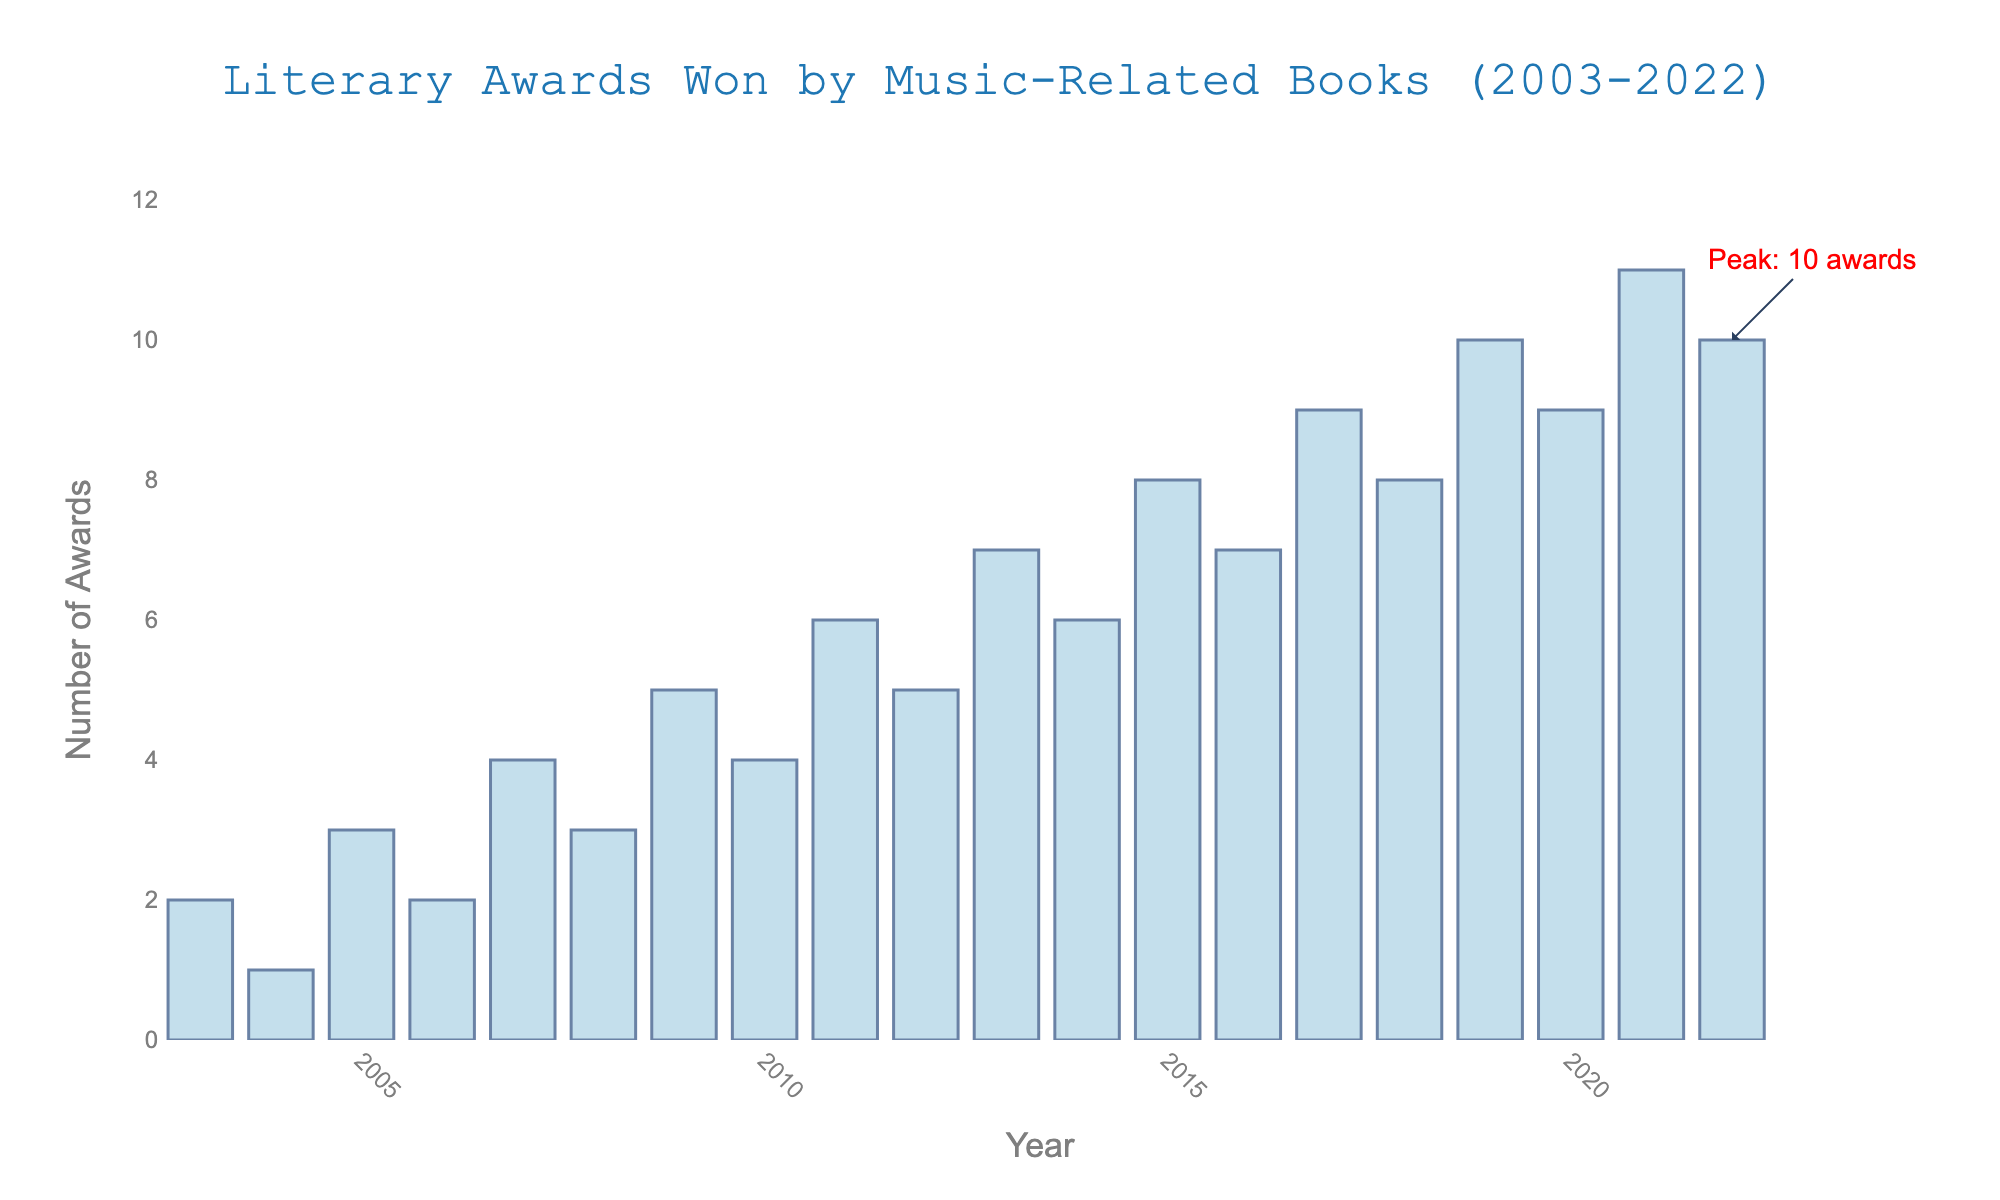How many awards were won by music-related books in 2022? Look at the bar corresponding to the year 2022 and read off the number of awards.
Answer: 10 Which year saw the highest number of awards? Find the tallest bar in the chart which corresponds to the year with the highest number of awards. The annotation on the chart also highlights the peak.
Answer: 2021 How many more awards were won in 2019 compared to 2015? Identify the number of awards in 2019 (10) and 2015 (8) from the respective bars and subtract to find the difference.
Answer: 2 What is the average number of awards won per year from 2003 to 2022? Sum the total number of awards from all years and divide by the number of years (20). Total awards: 2+1+3+2+4+3+5+4+6+5+7+6+8+7+9+8+10+9+11+10 = 120. Average = 120/20.
Answer: 6 Which year had twice as many awards as 2008? Identify the number of awards in 2008 (3) and find the year with twice that number (6). The year with 6 awards is 2011 and 2014.
Answer: 2011 and 2014 Is the number of awards won in 2009 greater than or equal to the number of awards in 2010? Compare the heights of the bars for 2009 (5 awards) and 2010 (4 awards).
Answer: Yes How many years saw more than 7 awards won? Count the number of bars that extend above the 7 awards mark: 2015, 2016, 2017, 2018, 2019, 2020, 2021, 2022.
Answer: 8 What is the total number of awards won in the first 10 years (2003-2012)? Sum the number of awards from 2003 to 2012: 2+1+3+2+4+3+5+4+6+5 = 35.
Answer: 35 Between which consecutive years did the number of awards increase the most? Compute the differences in the number of awards between consecutive years and identify the largest increase. The largest increase, 2015 to 2016, is by (7-8=1) and from 2018 to 2019, it jumps from 8 to 10, an increase of 2.
Answer: 2018 to 2019 